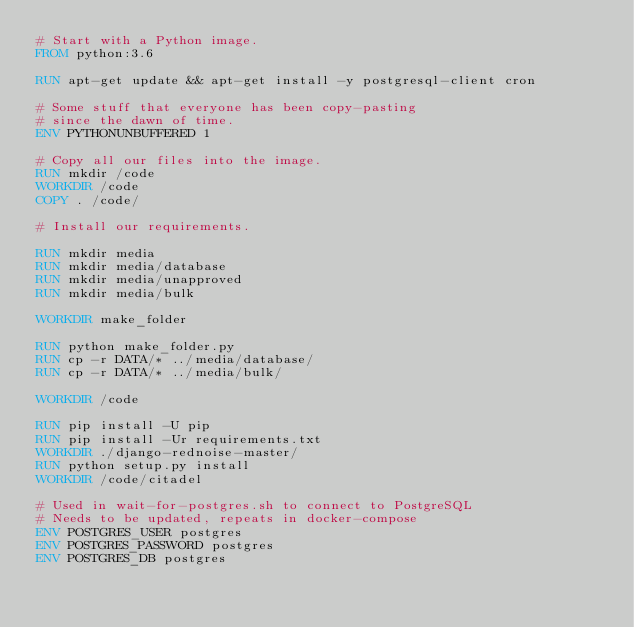<code> <loc_0><loc_0><loc_500><loc_500><_Dockerfile_># Start with a Python image.
FROM python:3.6

RUN apt-get update && apt-get install -y postgresql-client cron

# Some stuff that everyone has been copy-pasting
# since the dawn of time.
ENV PYTHONUNBUFFERED 1

# Copy all our files into the image.
RUN mkdir /code
WORKDIR /code
COPY . /code/

# Install our requirements.

RUN mkdir media
RUN mkdir media/database
RUN mkdir media/unapproved
RUN mkdir media/bulk

WORKDIR make_folder

RUN python make_folder.py
RUN cp -r DATA/* ../media/database/
RUN cp -r DATA/* ../media/bulk/

WORKDIR /code

RUN pip install -U pip
RUN pip install -Ur requirements.txt
WORKDIR ./django-rednoise-master/
RUN python setup.py install
WORKDIR /code/citadel

# Used in wait-for-postgres.sh to connect to PostgreSQL
# Needs to be updated, repeats in docker-compose
ENV POSTGRES_USER postgres
ENV POSTGRES_PASSWORD postgres
ENV POSTGRES_DB postgres
</code> 